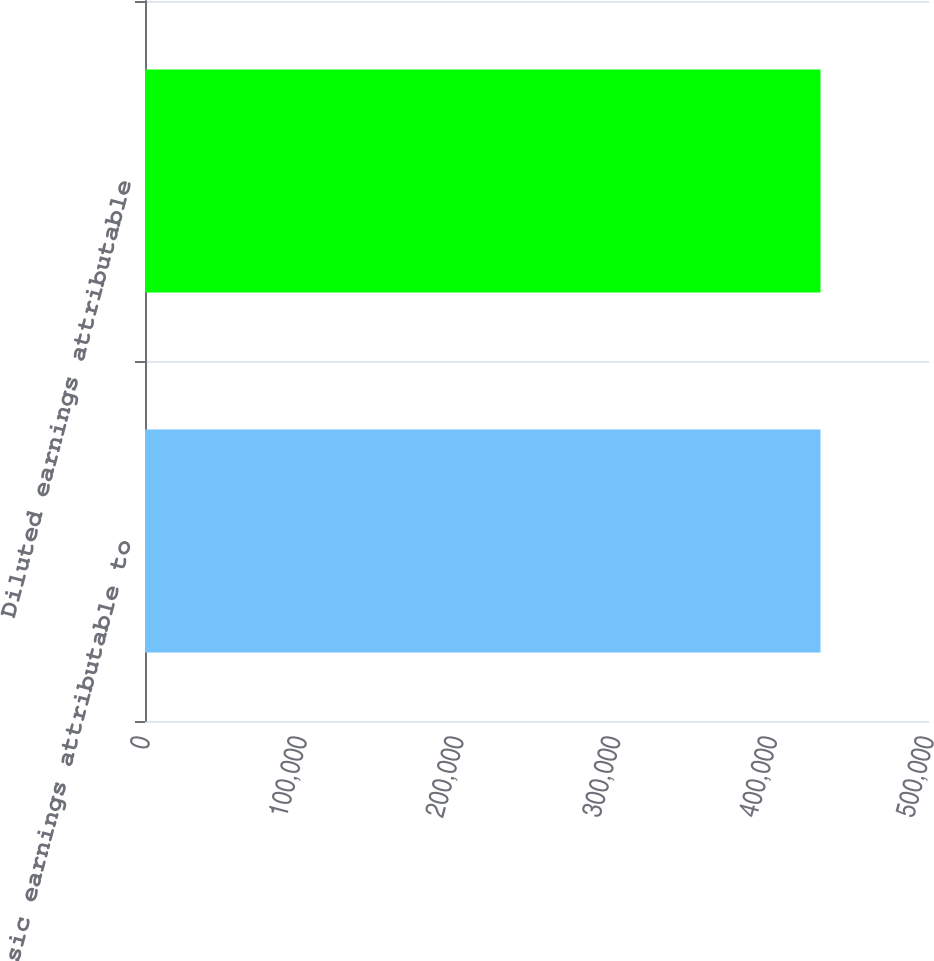Convert chart. <chart><loc_0><loc_0><loc_500><loc_500><bar_chart><fcel>Basic earnings attributable to<fcel>Diluted earnings attributable<nl><fcel>430807<fcel>430807<nl></chart> 